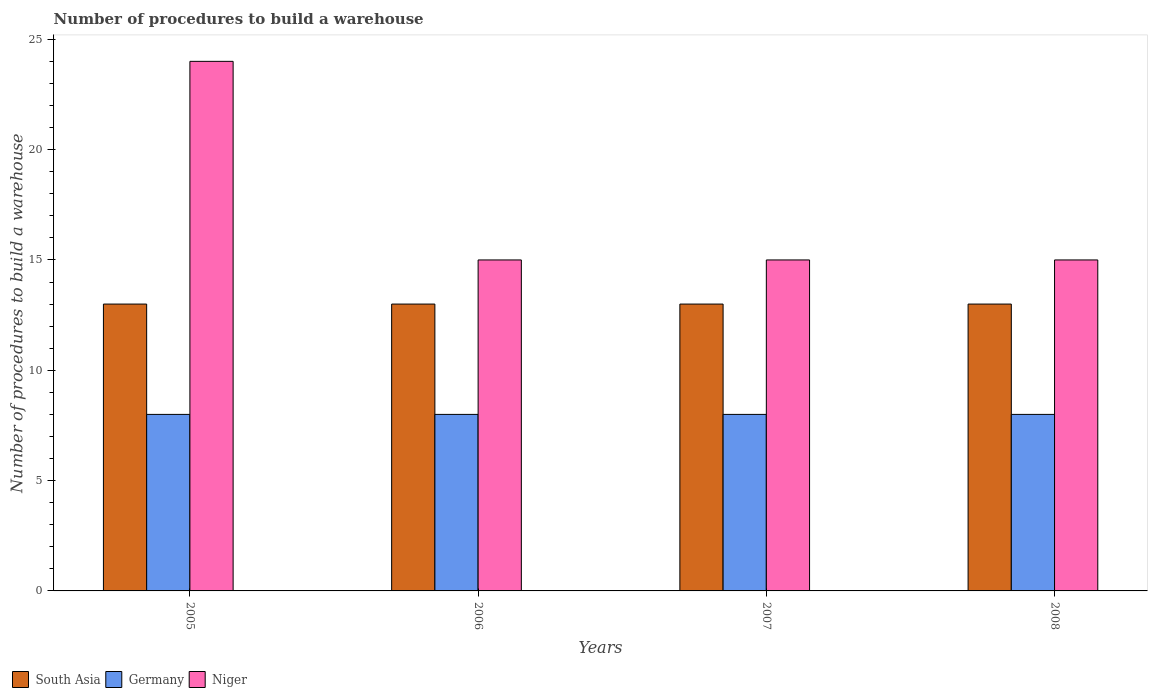Are the number of bars on each tick of the X-axis equal?
Your answer should be compact. Yes. How many bars are there on the 2nd tick from the left?
Your response must be concise. 3. What is the label of the 4th group of bars from the left?
Provide a succinct answer. 2008. In how many cases, is the number of bars for a given year not equal to the number of legend labels?
Offer a terse response. 0. What is the number of procedures to build a warehouse in in South Asia in 2008?
Provide a succinct answer. 13. Across all years, what is the maximum number of procedures to build a warehouse in in Germany?
Keep it short and to the point. 8. Across all years, what is the minimum number of procedures to build a warehouse in in Niger?
Provide a succinct answer. 15. In which year was the number of procedures to build a warehouse in in South Asia maximum?
Make the answer very short. 2005. In which year was the number of procedures to build a warehouse in in Germany minimum?
Make the answer very short. 2005. What is the total number of procedures to build a warehouse in in Germany in the graph?
Offer a terse response. 32. What is the difference between the number of procedures to build a warehouse in in Germany in 2007 and the number of procedures to build a warehouse in in South Asia in 2006?
Ensure brevity in your answer.  -5. What is the average number of procedures to build a warehouse in in Niger per year?
Offer a very short reply. 17.25. What is the ratio of the number of procedures to build a warehouse in in South Asia in 2005 to that in 2007?
Offer a very short reply. 1. Is the difference between the number of procedures to build a warehouse in in South Asia in 2005 and 2007 greater than the difference between the number of procedures to build a warehouse in in Niger in 2005 and 2007?
Ensure brevity in your answer.  No. Is the sum of the number of procedures to build a warehouse in in South Asia in 2006 and 2007 greater than the maximum number of procedures to build a warehouse in in Germany across all years?
Offer a terse response. Yes. What does the 3rd bar from the left in 2006 represents?
Your answer should be very brief. Niger. What does the 1st bar from the right in 2005 represents?
Your response must be concise. Niger. Is it the case that in every year, the sum of the number of procedures to build a warehouse in in Niger and number of procedures to build a warehouse in in South Asia is greater than the number of procedures to build a warehouse in in Germany?
Make the answer very short. Yes. How many bars are there?
Keep it short and to the point. 12. What is the difference between two consecutive major ticks on the Y-axis?
Make the answer very short. 5. Are the values on the major ticks of Y-axis written in scientific E-notation?
Ensure brevity in your answer.  No. Does the graph contain any zero values?
Provide a short and direct response. No. Does the graph contain grids?
Give a very brief answer. No. How many legend labels are there?
Provide a succinct answer. 3. What is the title of the graph?
Offer a very short reply. Number of procedures to build a warehouse. Does "Colombia" appear as one of the legend labels in the graph?
Your answer should be very brief. No. What is the label or title of the Y-axis?
Provide a short and direct response. Number of procedures to build a warehouse. What is the Number of procedures to build a warehouse in Germany in 2005?
Ensure brevity in your answer.  8. What is the Number of procedures to build a warehouse of South Asia in 2006?
Offer a terse response. 13. What is the Number of procedures to build a warehouse of Germany in 2007?
Offer a terse response. 8. What is the Number of procedures to build a warehouse in South Asia in 2008?
Give a very brief answer. 13. What is the Number of procedures to build a warehouse in Germany in 2008?
Ensure brevity in your answer.  8. What is the Number of procedures to build a warehouse in Niger in 2008?
Offer a terse response. 15. Across all years, what is the minimum Number of procedures to build a warehouse of South Asia?
Offer a terse response. 13. Across all years, what is the minimum Number of procedures to build a warehouse of Germany?
Offer a very short reply. 8. Across all years, what is the minimum Number of procedures to build a warehouse in Niger?
Make the answer very short. 15. What is the total Number of procedures to build a warehouse of Niger in the graph?
Your answer should be very brief. 69. What is the difference between the Number of procedures to build a warehouse of Germany in 2005 and that in 2006?
Provide a succinct answer. 0. What is the difference between the Number of procedures to build a warehouse of South Asia in 2005 and that in 2007?
Your answer should be compact. 0. What is the difference between the Number of procedures to build a warehouse of Niger in 2005 and that in 2007?
Ensure brevity in your answer.  9. What is the difference between the Number of procedures to build a warehouse of South Asia in 2005 and that in 2008?
Your answer should be compact. 0. What is the difference between the Number of procedures to build a warehouse of South Asia in 2006 and that in 2008?
Your answer should be compact. 0. What is the difference between the Number of procedures to build a warehouse in Germany in 2006 and that in 2008?
Ensure brevity in your answer.  0. What is the difference between the Number of procedures to build a warehouse of Niger in 2006 and that in 2008?
Give a very brief answer. 0. What is the difference between the Number of procedures to build a warehouse of South Asia in 2007 and that in 2008?
Your answer should be very brief. 0. What is the difference between the Number of procedures to build a warehouse of Germany in 2007 and that in 2008?
Your answer should be compact. 0. What is the difference between the Number of procedures to build a warehouse of Niger in 2007 and that in 2008?
Provide a succinct answer. 0. What is the difference between the Number of procedures to build a warehouse of South Asia in 2005 and the Number of procedures to build a warehouse of Germany in 2006?
Make the answer very short. 5. What is the difference between the Number of procedures to build a warehouse in South Asia in 2005 and the Number of procedures to build a warehouse in Niger in 2006?
Your answer should be compact. -2. What is the difference between the Number of procedures to build a warehouse of South Asia in 2005 and the Number of procedures to build a warehouse of Germany in 2007?
Your answer should be very brief. 5. What is the difference between the Number of procedures to build a warehouse of Germany in 2005 and the Number of procedures to build a warehouse of Niger in 2007?
Your response must be concise. -7. What is the difference between the Number of procedures to build a warehouse in Germany in 2006 and the Number of procedures to build a warehouse in Niger in 2007?
Provide a succinct answer. -7. What is the difference between the Number of procedures to build a warehouse in South Asia in 2006 and the Number of procedures to build a warehouse in Germany in 2008?
Provide a short and direct response. 5. What is the difference between the Number of procedures to build a warehouse of South Asia in 2006 and the Number of procedures to build a warehouse of Niger in 2008?
Keep it short and to the point. -2. What is the difference between the Number of procedures to build a warehouse of Germany in 2006 and the Number of procedures to build a warehouse of Niger in 2008?
Make the answer very short. -7. What is the average Number of procedures to build a warehouse in South Asia per year?
Offer a terse response. 13. What is the average Number of procedures to build a warehouse in Germany per year?
Provide a succinct answer. 8. What is the average Number of procedures to build a warehouse of Niger per year?
Your response must be concise. 17.25. In the year 2005, what is the difference between the Number of procedures to build a warehouse in South Asia and Number of procedures to build a warehouse in Germany?
Offer a terse response. 5. In the year 2005, what is the difference between the Number of procedures to build a warehouse in Germany and Number of procedures to build a warehouse in Niger?
Your response must be concise. -16. In the year 2006, what is the difference between the Number of procedures to build a warehouse of Germany and Number of procedures to build a warehouse of Niger?
Offer a terse response. -7. In the year 2007, what is the difference between the Number of procedures to build a warehouse in South Asia and Number of procedures to build a warehouse in Germany?
Your answer should be very brief. 5. What is the ratio of the Number of procedures to build a warehouse in South Asia in 2005 to that in 2006?
Provide a succinct answer. 1. What is the ratio of the Number of procedures to build a warehouse in Germany in 2005 to that in 2007?
Give a very brief answer. 1. What is the ratio of the Number of procedures to build a warehouse in South Asia in 2006 to that in 2007?
Keep it short and to the point. 1. What is the ratio of the Number of procedures to build a warehouse in Germany in 2006 to that in 2008?
Provide a short and direct response. 1. What is the ratio of the Number of procedures to build a warehouse in Niger in 2006 to that in 2008?
Your response must be concise. 1. What is the ratio of the Number of procedures to build a warehouse of Niger in 2007 to that in 2008?
Make the answer very short. 1. What is the difference between the highest and the second highest Number of procedures to build a warehouse in South Asia?
Provide a short and direct response. 0. What is the difference between the highest and the second highest Number of procedures to build a warehouse in Germany?
Make the answer very short. 0. What is the difference between the highest and the second highest Number of procedures to build a warehouse of Niger?
Your answer should be very brief. 9. What is the difference between the highest and the lowest Number of procedures to build a warehouse of Germany?
Your response must be concise. 0. What is the difference between the highest and the lowest Number of procedures to build a warehouse in Niger?
Provide a short and direct response. 9. 